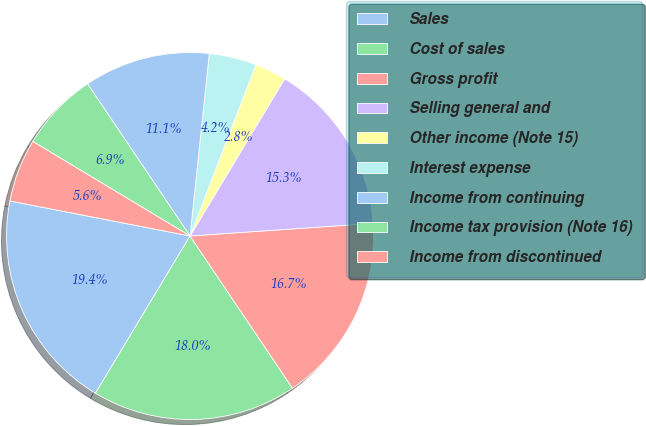Convert chart to OTSL. <chart><loc_0><loc_0><loc_500><loc_500><pie_chart><fcel>Sales<fcel>Cost of sales<fcel>Gross profit<fcel>Selling general and<fcel>Other income (Note 15)<fcel>Interest expense<fcel>Income from continuing<fcel>Income tax provision (Note 16)<fcel>Income from discontinued<nl><fcel>19.44%<fcel>18.05%<fcel>16.67%<fcel>15.28%<fcel>2.78%<fcel>4.17%<fcel>11.11%<fcel>6.95%<fcel>5.56%<nl></chart> 